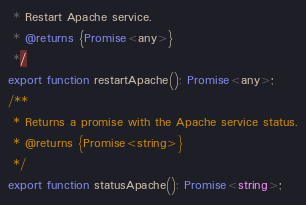Convert code to text. <code><loc_0><loc_0><loc_500><loc_500><_TypeScript_> * Restart Apache service.
 * @returns {Promise<any>}
 */
export function restartApache(): Promise<any>;
/**
 * Returns a promise with the Apache service status.
 * @returns {Promise<string>}
 */
export function statusApache(): Promise<string>;
</code> 